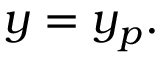Convert formula to latex. <formula><loc_0><loc_0><loc_500><loc_500>y = y _ { p } .</formula> 